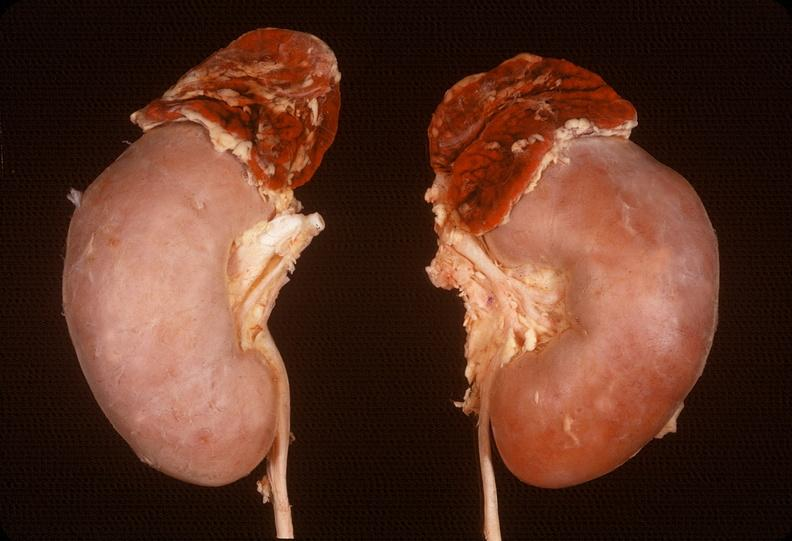s intraductal papillomatosis with apocrine metaplasia present?
Answer the question using a single word or phrase. No 